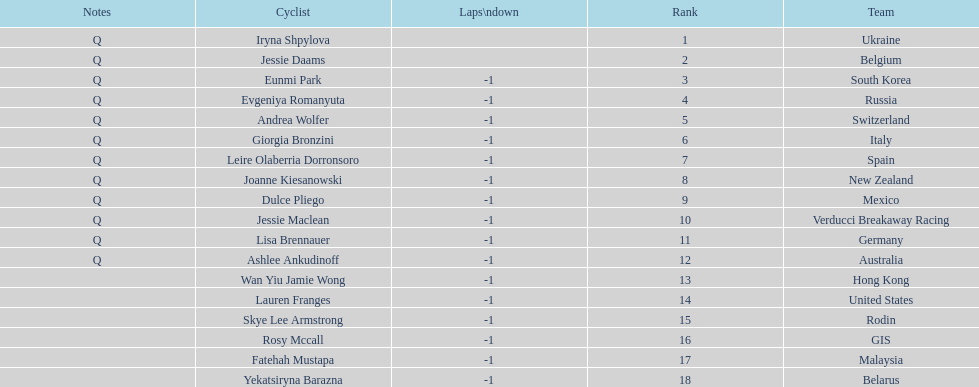Who was the first competitor to finish the race a lap behind? Eunmi Park. 